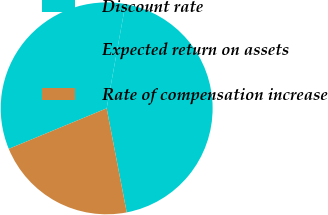Convert chart. <chart><loc_0><loc_0><loc_500><loc_500><pie_chart><fcel>Discount rate<fcel>Expected return on assets<fcel>Rate of compensation increase<nl><fcel>34.08%<fcel>44.13%<fcel>21.79%<nl></chart> 